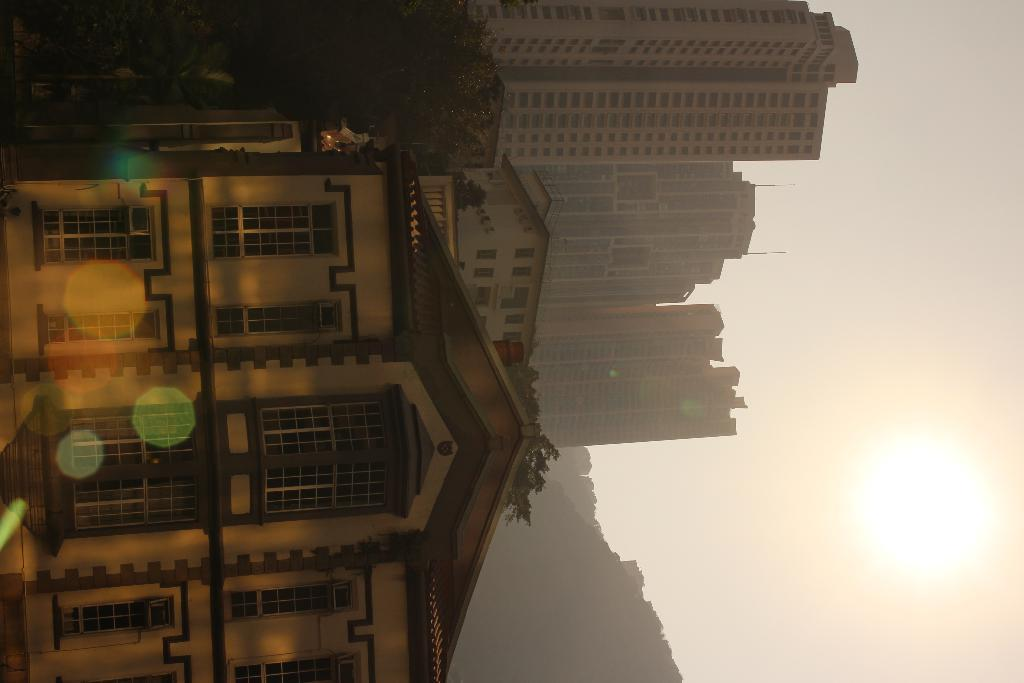What type of structures can be seen in the image? There are buildings in the image. What other natural elements are present in the image? There are trees in the image. What part of the sky is visible in the image? The sky is visible on the right side of the image. What celestial body can be seen in the sky on the right side of the image? The sun is visible in the sky on the right side of the image. What type of wing is attached to the dad in the image? There is no dad or wing present in the image. How many bricks are visible in the image? The provided facts do not mention the presence of bricks in the image. 